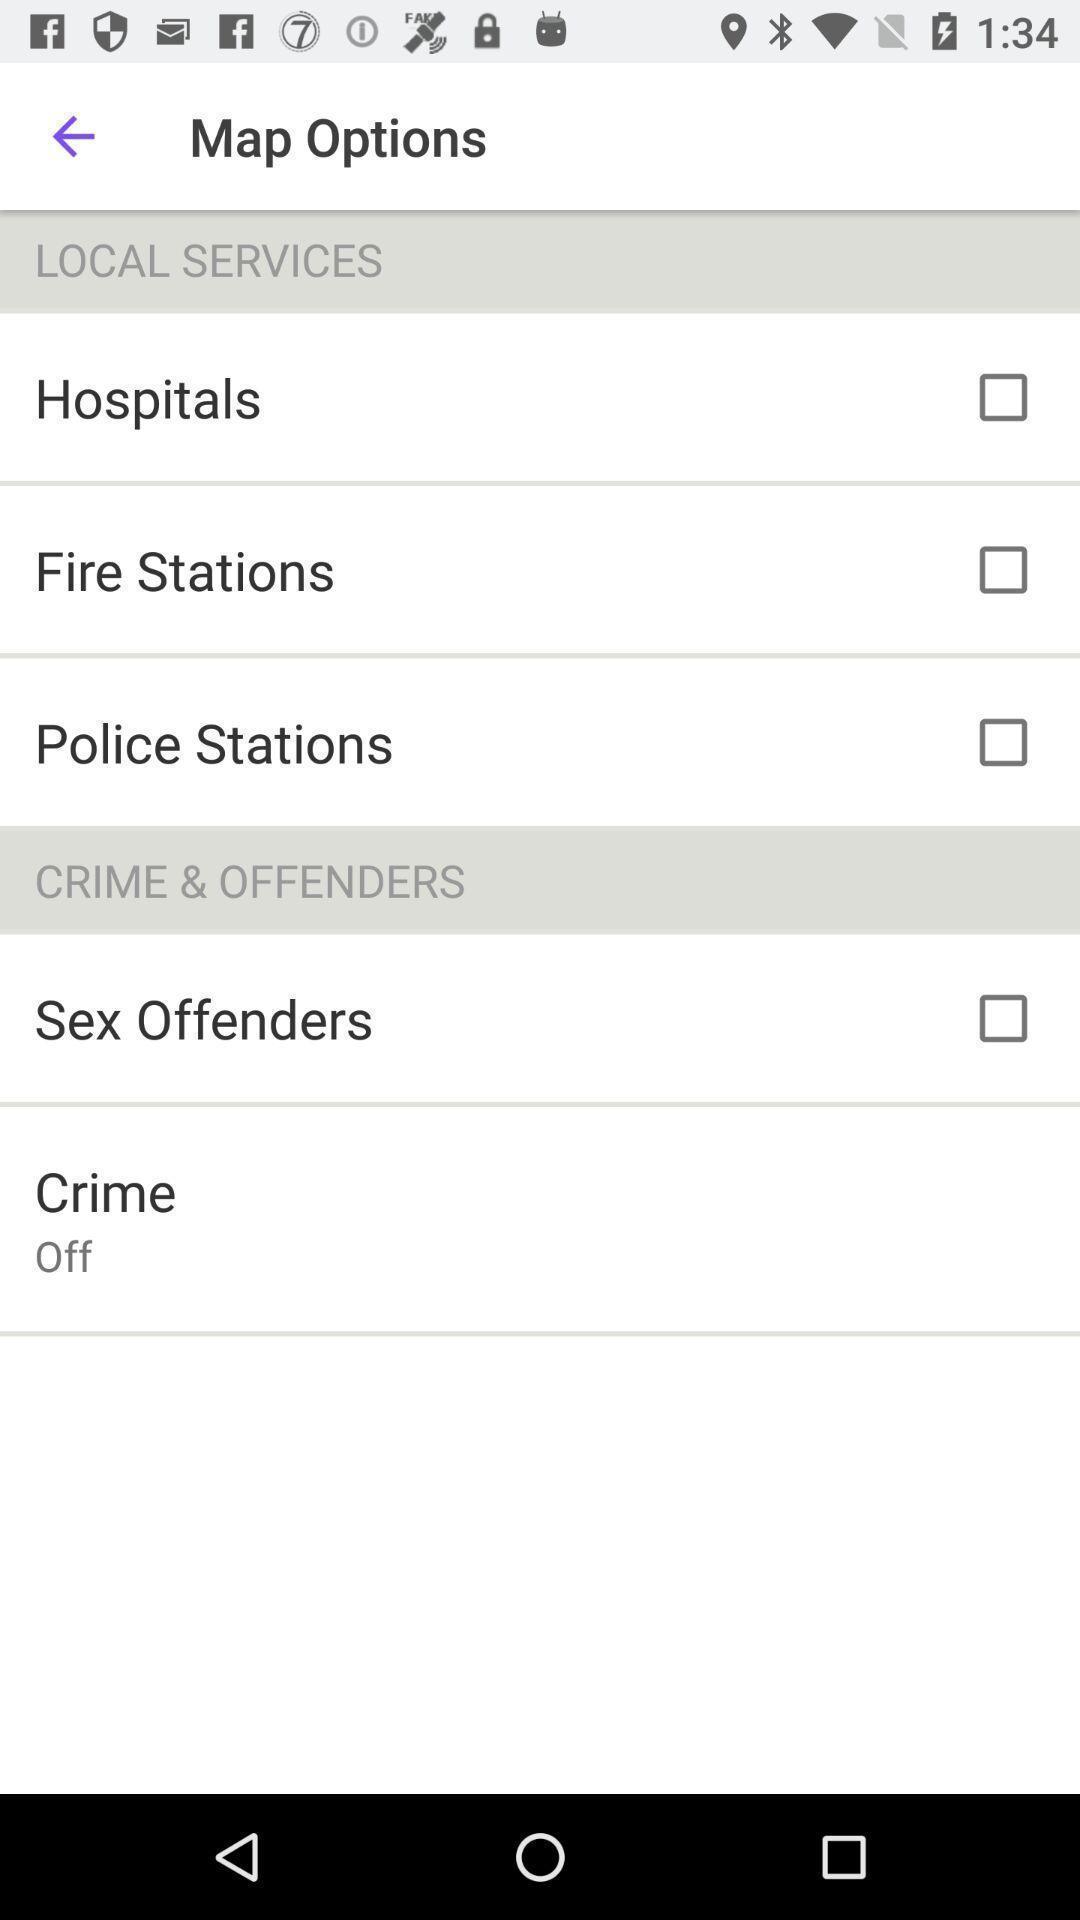Summarize the information in this screenshot. Page showing different map options on an app. 